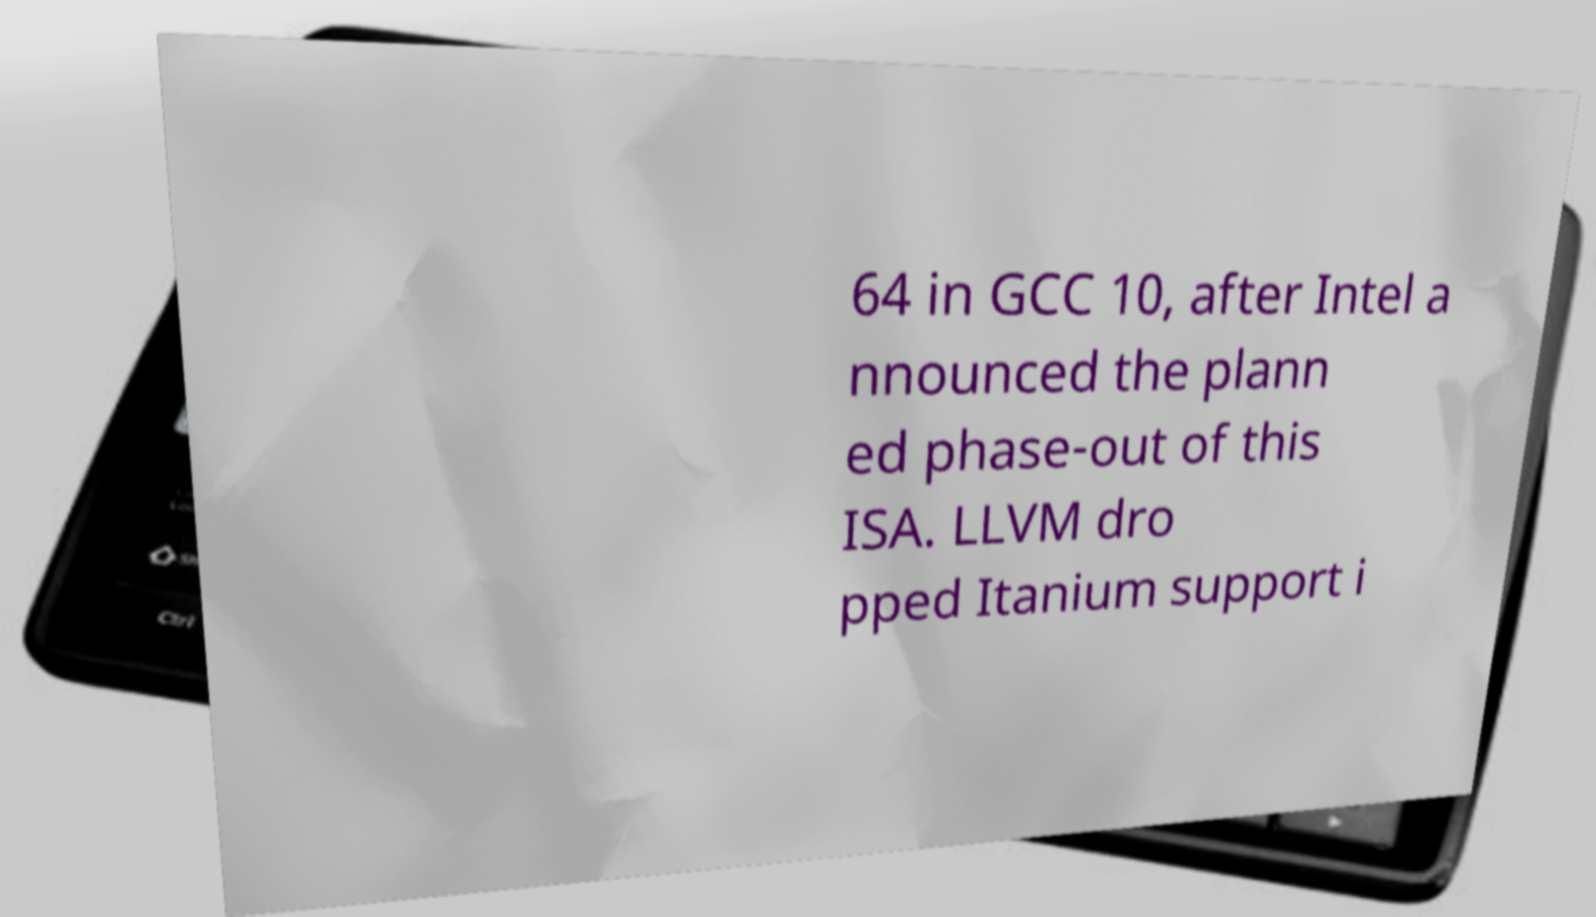What messages or text are displayed in this image? I need them in a readable, typed format. 64 in GCC 10, after Intel a nnounced the plann ed phase-out of this ISA. LLVM dro pped Itanium support i 